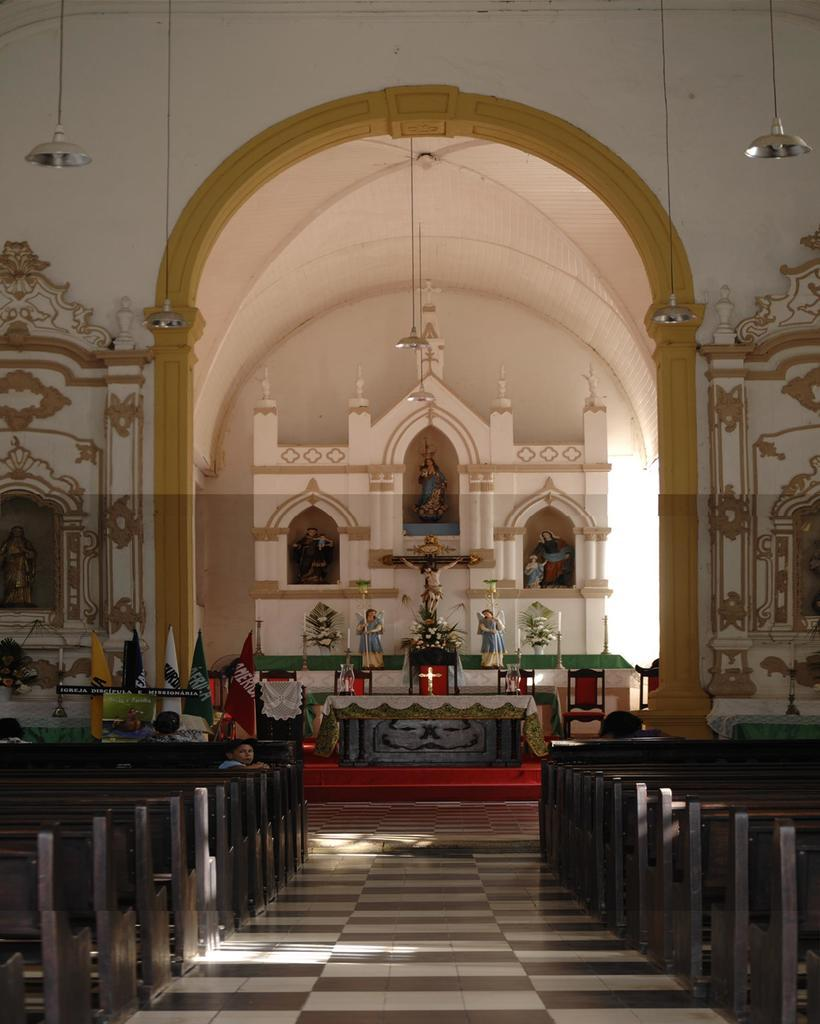What type of seating is present in the image? There are benches in the image. Who or what can be seen in the image? There are people and statues in the image. What decorative elements are present in the image? There are flags in the image. What can be seen in the background of the image? There is a wall visible in the background of the image. What type of frame is being used by the minister in the image? There is no minister or frame present in the image. How many cubs are visible in the image? There are no cubs present in the image. 